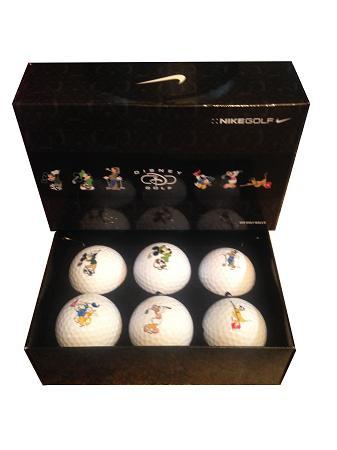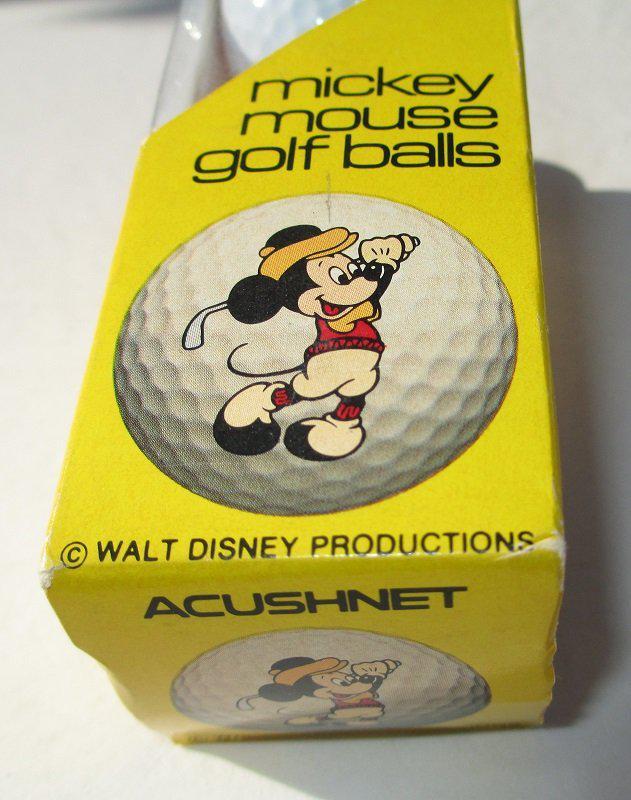The first image is the image on the left, the second image is the image on the right. For the images displayed, is the sentence "There is one golf ball with ears." factually correct? Answer yes or no. No. 